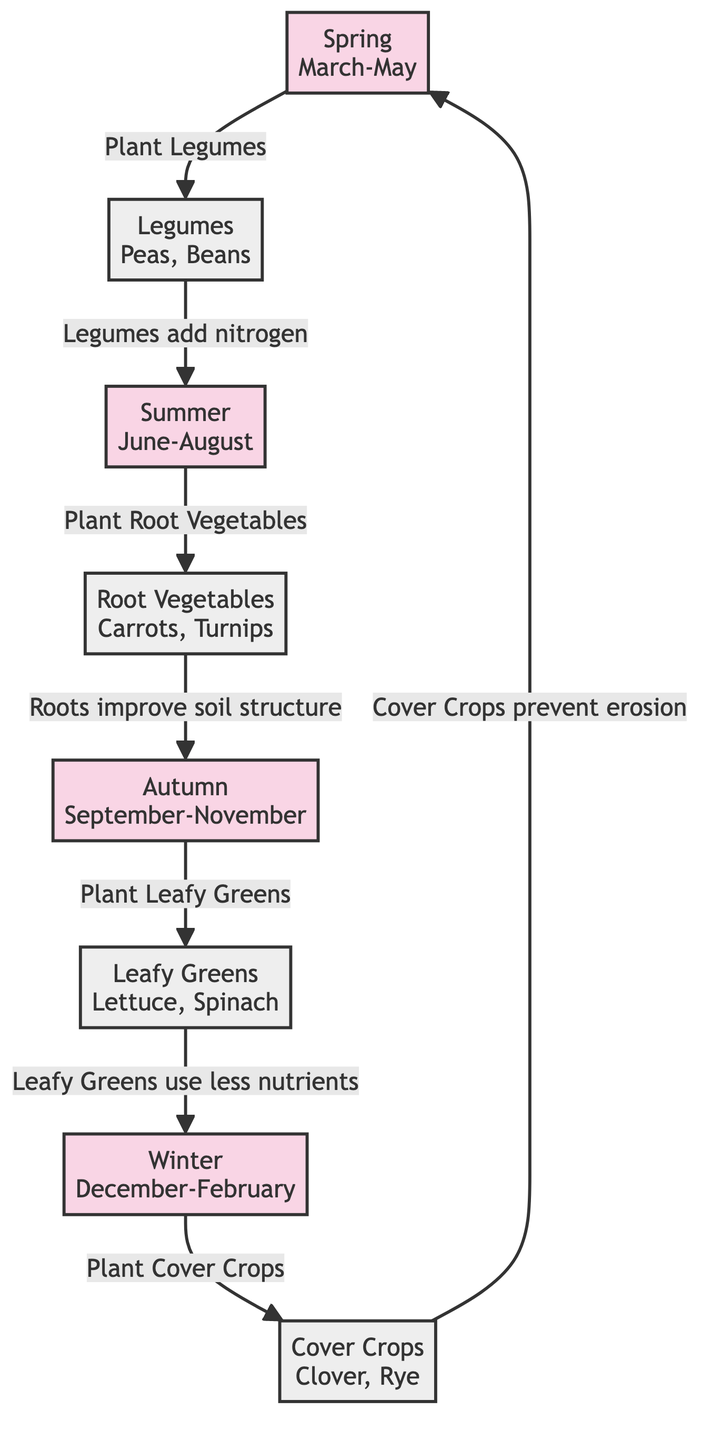What crops are planted in spring? The diagram indicates that legumes (such as peas and beans) are planted in the spring season (March-May). The arrow directs from Spring to Legumes, making this clear.
Answer: Legumes What improves soil structure after planting? According to the diagram, root vegetables (like carrots and turnips) are responsible for improving soil structure after they are planted in Autumn (September-November). The arrow indicates the relationship between Root Vegetables and soil structure improvement.
Answer: Roots Which season do you plant cover crops? The diagram shows that cover crops (like clover and rye) are planted in winter (December-February). This is indicated by the arrow leading from Winter to Cover Crops.
Answer: Winter How many types of crops are mentioned in the diagram? There are four types of crops identified in the diagram: Legumes, Leafy Greens, Root Vegetables, and Cover Crops. By counting the crop nodes, we can determine this.
Answer: Four What nutrient benefit do legumes provide? The diagram states that legumes add nitrogen, which is a crucial nutrient for soil health. This is indicated by the arrow from Legumes to the benefit they provide.
Answer: Nitrogen What seasonal breakdown occurs after planting leafy greens? After planting leafy greens in Autumn, according to the diagram, they use less nutrients, which is indicated by the flow from Leafy Greens to the resulting benefit.
Answer: Less nutrients Which crops prevent erosion and in which season? The cover crops, planted in winter, are specified in the diagram to prevent erosion. This is shown by the arrow linking Cover Crops to the benefit of erosion prevention.
Answer: Cover Crops in Winter What is the relationship between root vegetables and the season? The diagram indicates that root vegetables are planted in summer (June-August) and contribute to improving soil structure, demonstrating a flow from summer to root vegetables and then to the benefit.
Answer: Summer to improve soil structure Which crop is associated with planting in summer in this rotation cycle? The diagram specifies that root vegetables are planted in summer, showing an arrow from Summer directing to Root Vegetables.
Answer: Root Vegetables 